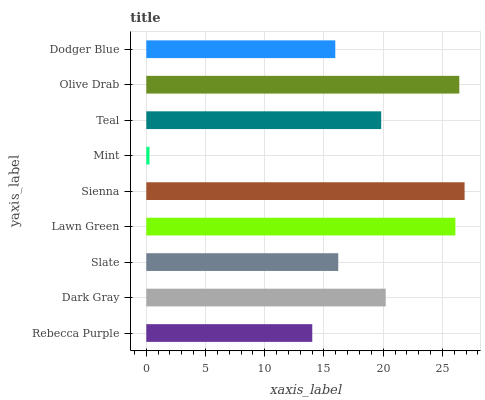Is Mint the minimum?
Answer yes or no. Yes. Is Sienna the maximum?
Answer yes or no. Yes. Is Dark Gray the minimum?
Answer yes or no. No. Is Dark Gray the maximum?
Answer yes or no. No. Is Dark Gray greater than Rebecca Purple?
Answer yes or no. Yes. Is Rebecca Purple less than Dark Gray?
Answer yes or no. Yes. Is Rebecca Purple greater than Dark Gray?
Answer yes or no. No. Is Dark Gray less than Rebecca Purple?
Answer yes or no. No. Is Teal the high median?
Answer yes or no. Yes. Is Teal the low median?
Answer yes or no. Yes. Is Olive Drab the high median?
Answer yes or no. No. Is Sienna the low median?
Answer yes or no. No. 